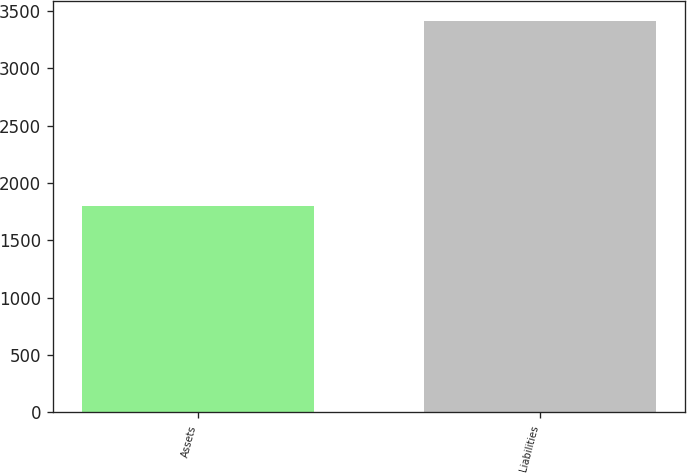Convert chart. <chart><loc_0><loc_0><loc_500><loc_500><bar_chart><fcel>Assets<fcel>Liabilities<nl><fcel>1795<fcel>3413<nl></chart> 